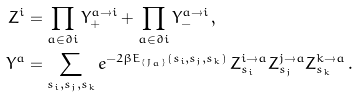<formula> <loc_0><loc_0><loc_500><loc_500>Z ^ { i } & = \prod _ { a \in \partial i } Y _ { + } ^ { a \to i } + \prod _ { a \in \partial i } Y _ { - } ^ { a \to i } \, , \\ Y ^ { a } & = \sum _ { s _ { i } , s _ { j } , s _ { k } } e ^ { - 2 \beta E _ { \{ J _ { a } \} } ( s _ { i } , s _ { j } , s _ { k } ) } \, Z _ { s _ { i } } ^ { i \to a } Z _ { s _ { j } } ^ { j \to a } Z _ { s _ { k } } ^ { k \to a } \, .</formula> 